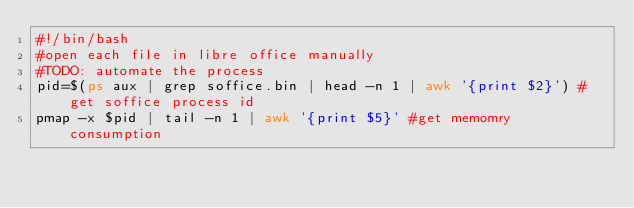Convert code to text. <code><loc_0><loc_0><loc_500><loc_500><_Bash_>#!/bin/bash
#open each file in libre office manually
#TODO: automate the process
pid=$(ps aux | grep soffice.bin | head -n 1 | awk '{print $2}') # get soffice process id
pmap -x $pid | tail -n 1 | awk '{print $5}' #get memomry consumption


</code> 